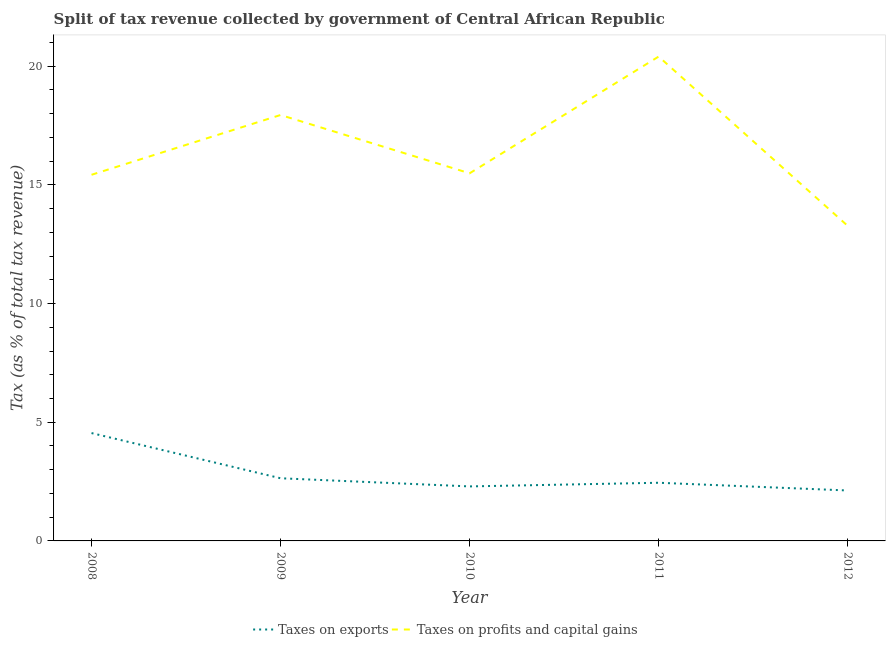What is the percentage of revenue obtained from taxes on profits and capital gains in 2010?
Provide a succinct answer. 15.49. Across all years, what is the maximum percentage of revenue obtained from taxes on exports?
Offer a very short reply. 4.54. Across all years, what is the minimum percentage of revenue obtained from taxes on profits and capital gains?
Your answer should be very brief. 13.27. What is the total percentage of revenue obtained from taxes on profits and capital gains in the graph?
Make the answer very short. 82.54. What is the difference between the percentage of revenue obtained from taxes on exports in 2008 and that in 2011?
Provide a succinct answer. 2.09. What is the difference between the percentage of revenue obtained from taxes on exports in 2009 and the percentage of revenue obtained from taxes on profits and capital gains in 2010?
Make the answer very short. -12.85. What is the average percentage of revenue obtained from taxes on exports per year?
Give a very brief answer. 2.81. In the year 2011, what is the difference between the percentage of revenue obtained from taxes on exports and percentage of revenue obtained from taxes on profits and capital gains?
Make the answer very short. -17.96. What is the ratio of the percentage of revenue obtained from taxes on profits and capital gains in 2008 to that in 2012?
Ensure brevity in your answer.  1.16. Is the difference between the percentage of revenue obtained from taxes on profits and capital gains in 2008 and 2009 greater than the difference between the percentage of revenue obtained from taxes on exports in 2008 and 2009?
Your response must be concise. No. What is the difference between the highest and the second highest percentage of revenue obtained from taxes on exports?
Your response must be concise. 1.9. What is the difference between the highest and the lowest percentage of revenue obtained from taxes on profits and capital gains?
Make the answer very short. 7.13. Is the sum of the percentage of revenue obtained from taxes on profits and capital gains in 2008 and 2010 greater than the maximum percentage of revenue obtained from taxes on exports across all years?
Give a very brief answer. Yes. Is the percentage of revenue obtained from taxes on profits and capital gains strictly greater than the percentage of revenue obtained from taxes on exports over the years?
Your answer should be compact. Yes. Is the percentage of revenue obtained from taxes on profits and capital gains strictly less than the percentage of revenue obtained from taxes on exports over the years?
Keep it short and to the point. No. How many lines are there?
Your answer should be very brief. 2. Does the graph contain any zero values?
Ensure brevity in your answer.  No. How many legend labels are there?
Offer a very short reply. 2. What is the title of the graph?
Keep it short and to the point. Split of tax revenue collected by government of Central African Republic. Does "Primary completion rate" appear as one of the legend labels in the graph?
Your answer should be very brief. No. What is the label or title of the Y-axis?
Ensure brevity in your answer.  Tax (as % of total tax revenue). What is the Tax (as % of total tax revenue) in Taxes on exports in 2008?
Provide a succinct answer. 4.54. What is the Tax (as % of total tax revenue) in Taxes on profits and capital gains in 2008?
Provide a succinct answer. 15.43. What is the Tax (as % of total tax revenue) in Taxes on exports in 2009?
Provide a short and direct response. 2.64. What is the Tax (as % of total tax revenue) in Taxes on profits and capital gains in 2009?
Your answer should be very brief. 17.95. What is the Tax (as % of total tax revenue) of Taxes on exports in 2010?
Give a very brief answer. 2.3. What is the Tax (as % of total tax revenue) of Taxes on profits and capital gains in 2010?
Provide a succinct answer. 15.49. What is the Tax (as % of total tax revenue) in Taxes on exports in 2011?
Offer a very short reply. 2.45. What is the Tax (as % of total tax revenue) in Taxes on profits and capital gains in 2011?
Give a very brief answer. 20.41. What is the Tax (as % of total tax revenue) of Taxes on exports in 2012?
Your response must be concise. 2.13. What is the Tax (as % of total tax revenue) of Taxes on profits and capital gains in 2012?
Make the answer very short. 13.27. Across all years, what is the maximum Tax (as % of total tax revenue) in Taxes on exports?
Your answer should be very brief. 4.54. Across all years, what is the maximum Tax (as % of total tax revenue) in Taxes on profits and capital gains?
Offer a very short reply. 20.41. Across all years, what is the minimum Tax (as % of total tax revenue) in Taxes on exports?
Keep it short and to the point. 2.13. Across all years, what is the minimum Tax (as % of total tax revenue) of Taxes on profits and capital gains?
Your answer should be very brief. 13.27. What is the total Tax (as % of total tax revenue) of Taxes on exports in the graph?
Offer a very short reply. 14.06. What is the total Tax (as % of total tax revenue) of Taxes on profits and capital gains in the graph?
Offer a terse response. 82.54. What is the difference between the Tax (as % of total tax revenue) in Taxes on exports in 2008 and that in 2009?
Offer a very short reply. 1.9. What is the difference between the Tax (as % of total tax revenue) of Taxes on profits and capital gains in 2008 and that in 2009?
Ensure brevity in your answer.  -2.52. What is the difference between the Tax (as % of total tax revenue) in Taxes on exports in 2008 and that in 2010?
Provide a short and direct response. 2.25. What is the difference between the Tax (as % of total tax revenue) of Taxes on profits and capital gains in 2008 and that in 2010?
Offer a terse response. -0.06. What is the difference between the Tax (as % of total tax revenue) in Taxes on exports in 2008 and that in 2011?
Your answer should be very brief. 2.09. What is the difference between the Tax (as % of total tax revenue) in Taxes on profits and capital gains in 2008 and that in 2011?
Provide a short and direct response. -4.98. What is the difference between the Tax (as % of total tax revenue) in Taxes on exports in 2008 and that in 2012?
Make the answer very short. 2.42. What is the difference between the Tax (as % of total tax revenue) of Taxes on profits and capital gains in 2008 and that in 2012?
Provide a short and direct response. 2.15. What is the difference between the Tax (as % of total tax revenue) of Taxes on exports in 2009 and that in 2010?
Your answer should be very brief. 0.34. What is the difference between the Tax (as % of total tax revenue) in Taxes on profits and capital gains in 2009 and that in 2010?
Provide a short and direct response. 2.46. What is the difference between the Tax (as % of total tax revenue) of Taxes on exports in 2009 and that in 2011?
Offer a terse response. 0.19. What is the difference between the Tax (as % of total tax revenue) of Taxes on profits and capital gains in 2009 and that in 2011?
Make the answer very short. -2.46. What is the difference between the Tax (as % of total tax revenue) in Taxes on exports in 2009 and that in 2012?
Keep it short and to the point. 0.51. What is the difference between the Tax (as % of total tax revenue) in Taxes on profits and capital gains in 2009 and that in 2012?
Provide a succinct answer. 4.67. What is the difference between the Tax (as % of total tax revenue) in Taxes on exports in 2010 and that in 2011?
Provide a succinct answer. -0.15. What is the difference between the Tax (as % of total tax revenue) in Taxes on profits and capital gains in 2010 and that in 2011?
Give a very brief answer. -4.92. What is the difference between the Tax (as % of total tax revenue) of Taxes on exports in 2010 and that in 2012?
Your answer should be very brief. 0.17. What is the difference between the Tax (as % of total tax revenue) in Taxes on profits and capital gains in 2010 and that in 2012?
Your answer should be compact. 2.21. What is the difference between the Tax (as % of total tax revenue) in Taxes on exports in 2011 and that in 2012?
Keep it short and to the point. 0.33. What is the difference between the Tax (as % of total tax revenue) in Taxes on profits and capital gains in 2011 and that in 2012?
Ensure brevity in your answer.  7.13. What is the difference between the Tax (as % of total tax revenue) in Taxes on exports in 2008 and the Tax (as % of total tax revenue) in Taxes on profits and capital gains in 2009?
Give a very brief answer. -13.4. What is the difference between the Tax (as % of total tax revenue) in Taxes on exports in 2008 and the Tax (as % of total tax revenue) in Taxes on profits and capital gains in 2010?
Make the answer very short. -10.94. What is the difference between the Tax (as % of total tax revenue) of Taxes on exports in 2008 and the Tax (as % of total tax revenue) of Taxes on profits and capital gains in 2011?
Your answer should be compact. -15.86. What is the difference between the Tax (as % of total tax revenue) of Taxes on exports in 2008 and the Tax (as % of total tax revenue) of Taxes on profits and capital gains in 2012?
Your answer should be compact. -8.73. What is the difference between the Tax (as % of total tax revenue) of Taxes on exports in 2009 and the Tax (as % of total tax revenue) of Taxes on profits and capital gains in 2010?
Your answer should be very brief. -12.85. What is the difference between the Tax (as % of total tax revenue) of Taxes on exports in 2009 and the Tax (as % of total tax revenue) of Taxes on profits and capital gains in 2011?
Provide a short and direct response. -17.77. What is the difference between the Tax (as % of total tax revenue) in Taxes on exports in 2009 and the Tax (as % of total tax revenue) in Taxes on profits and capital gains in 2012?
Provide a succinct answer. -10.63. What is the difference between the Tax (as % of total tax revenue) in Taxes on exports in 2010 and the Tax (as % of total tax revenue) in Taxes on profits and capital gains in 2011?
Offer a very short reply. -18.11. What is the difference between the Tax (as % of total tax revenue) in Taxes on exports in 2010 and the Tax (as % of total tax revenue) in Taxes on profits and capital gains in 2012?
Your answer should be very brief. -10.98. What is the difference between the Tax (as % of total tax revenue) in Taxes on exports in 2011 and the Tax (as % of total tax revenue) in Taxes on profits and capital gains in 2012?
Provide a succinct answer. -10.82. What is the average Tax (as % of total tax revenue) in Taxes on exports per year?
Ensure brevity in your answer.  2.81. What is the average Tax (as % of total tax revenue) of Taxes on profits and capital gains per year?
Offer a terse response. 16.51. In the year 2008, what is the difference between the Tax (as % of total tax revenue) in Taxes on exports and Tax (as % of total tax revenue) in Taxes on profits and capital gains?
Provide a succinct answer. -10.88. In the year 2009, what is the difference between the Tax (as % of total tax revenue) of Taxes on exports and Tax (as % of total tax revenue) of Taxes on profits and capital gains?
Offer a very short reply. -15.31. In the year 2010, what is the difference between the Tax (as % of total tax revenue) in Taxes on exports and Tax (as % of total tax revenue) in Taxes on profits and capital gains?
Offer a very short reply. -13.19. In the year 2011, what is the difference between the Tax (as % of total tax revenue) in Taxes on exports and Tax (as % of total tax revenue) in Taxes on profits and capital gains?
Provide a short and direct response. -17.96. In the year 2012, what is the difference between the Tax (as % of total tax revenue) of Taxes on exports and Tax (as % of total tax revenue) of Taxes on profits and capital gains?
Offer a very short reply. -11.15. What is the ratio of the Tax (as % of total tax revenue) in Taxes on exports in 2008 to that in 2009?
Give a very brief answer. 1.72. What is the ratio of the Tax (as % of total tax revenue) in Taxes on profits and capital gains in 2008 to that in 2009?
Your response must be concise. 0.86. What is the ratio of the Tax (as % of total tax revenue) in Taxes on exports in 2008 to that in 2010?
Ensure brevity in your answer.  1.98. What is the ratio of the Tax (as % of total tax revenue) in Taxes on profits and capital gains in 2008 to that in 2010?
Your answer should be very brief. 1. What is the ratio of the Tax (as % of total tax revenue) in Taxes on exports in 2008 to that in 2011?
Your response must be concise. 1.85. What is the ratio of the Tax (as % of total tax revenue) of Taxes on profits and capital gains in 2008 to that in 2011?
Keep it short and to the point. 0.76. What is the ratio of the Tax (as % of total tax revenue) in Taxes on exports in 2008 to that in 2012?
Make the answer very short. 2.14. What is the ratio of the Tax (as % of total tax revenue) of Taxes on profits and capital gains in 2008 to that in 2012?
Keep it short and to the point. 1.16. What is the ratio of the Tax (as % of total tax revenue) of Taxes on exports in 2009 to that in 2010?
Give a very brief answer. 1.15. What is the ratio of the Tax (as % of total tax revenue) of Taxes on profits and capital gains in 2009 to that in 2010?
Ensure brevity in your answer.  1.16. What is the ratio of the Tax (as % of total tax revenue) of Taxes on exports in 2009 to that in 2011?
Provide a short and direct response. 1.08. What is the ratio of the Tax (as % of total tax revenue) in Taxes on profits and capital gains in 2009 to that in 2011?
Your answer should be compact. 0.88. What is the ratio of the Tax (as % of total tax revenue) in Taxes on exports in 2009 to that in 2012?
Offer a very short reply. 1.24. What is the ratio of the Tax (as % of total tax revenue) of Taxes on profits and capital gains in 2009 to that in 2012?
Provide a short and direct response. 1.35. What is the ratio of the Tax (as % of total tax revenue) of Taxes on exports in 2010 to that in 2011?
Offer a terse response. 0.94. What is the ratio of the Tax (as % of total tax revenue) in Taxes on profits and capital gains in 2010 to that in 2011?
Make the answer very short. 0.76. What is the ratio of the Tax (as % of total tax revenue) in Taxes on exports in 2010 to that in 2012?
Keep it short and to the point. 1.08. What is the ratio of the Tax (as % of total tax revenue) of Taxes on profits and capital gains in 2010 to that in 2012?
Your answer should be compact. 1.17. What is the ratio of the Tax (as % of total tax revenue) of Taxes on exports in 2011 to that in 2012?
Your answer should be very brief. 1.15. What is the ratio of the Tax (as % of total tax revenue) of Taxes on profits and capital gains in 2011 to that in 2012?
Provide a short and direct response. 1.54. What is the difference between the highest and the second highest Tax (as % of total tax revenue) in Taxes on exports?
Ensure brevity in your answer.  1.9. What is the difference between the highest and the second highest Tax (as % of total tax revenue) in Taxes on profits and capital gains?
Your answer should be very brief. 2.46. What is the difference between the highest and the lowest Tax (as % of total tax revenue) in Taxes on exports?
Your answer should be compact. 2.42. What is the difference between the highest and the lowest Tax (as % of total tax revenue) of Taxes on profits and capital gains?
Provide a succinct answer. 7.13. 